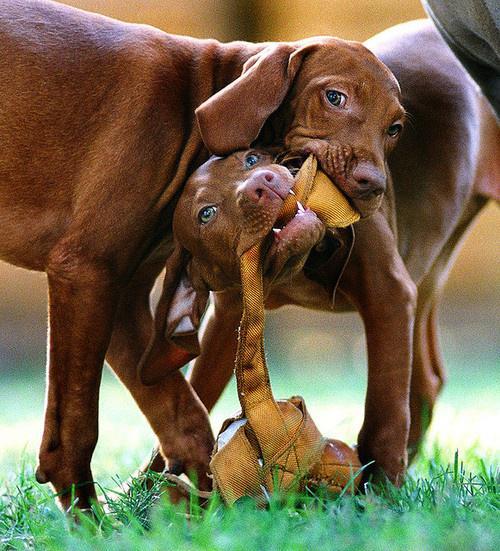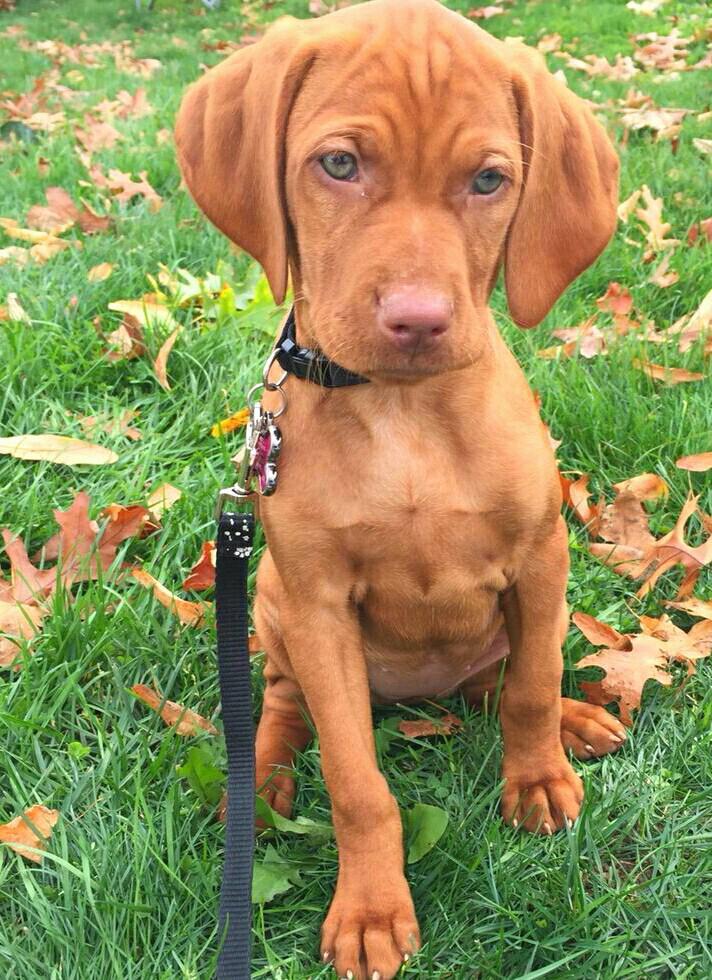The first image is the image on the left, the second image is the image on the right. Considering the images on both sides, is "One of the images shows a dog standing in green grass with a leg up in the air." valid? Answer yes or no. No. The first image is the image on the left, the second image is the image on the right. Evaluate the accuracy of this statement regarding the images: "One image shows a standing dog holding a long tan item in its mouth.". Is it true? Answer yes or no. Yes. 